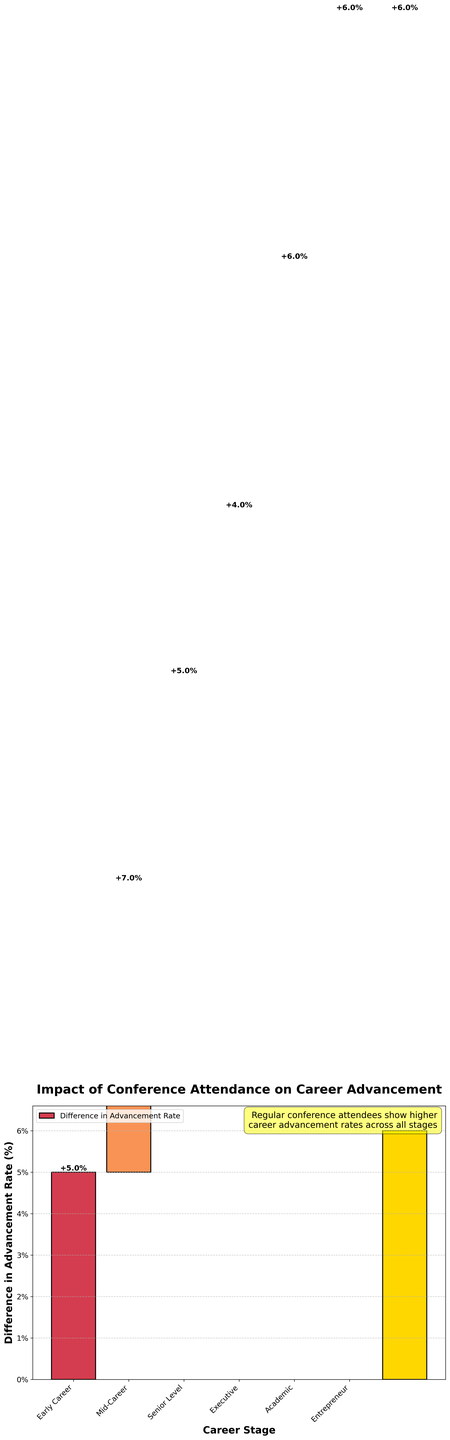What is the title of the figure? The title is usually positioned at the top of the figure and provides a summary of the main insight.
Answer: Impact of Conference Attendance on Career Advancement What does the y-axis represent? The y-axis label is provided to indicate what measurement is being shown vertical-wise in the plot.
Answer: Difference in Advancement Rate (%) Which career stage shows the highest difference in advancement rates between regular attendees and non-attendees? By examining the height of the bars, it's clear which career stage has the tallest bar.
Answer: Mid-Career How much is the difference in advancement rate at the Senior Level stage? Look at the specific bar for the Senior Level and check the label at the top of the bar.
Answer: 5% How many career stages are included in the analysis? Count the individual bars, excluding the total impact bar.
Answer: Six What is the total impact value for regular conference attendees vs. non-attendees? Look at the last bar, which represents the total impact, and read the value at the top of the bar.
Answer: 33% What is the combined difference in advancement rates for Academic and Entrepreneur stages? Find the values for both Academic and Entrepreneur stages, then add them together (6% + 6%).
Answer: 12% Which two career stages have equal differences in advancement rates between attendees and non-attendees? Compare the bars and identify which stages have the same height.
Answer: Early Career and Senior Level Is the difference in advancement rates higher for the Executive stage or the Early Career stage? Compare the heights of the bars for Executive and Early Career stages.
Answer: Early Career Explain why regular conference attendees have a higher career advancement rate across all stages, based on the figure. The figure shows consistently higher bars for regular attendees at each career stage, indicating a significant difference favoring conference attendees.
Answer: Conference attendees likely benefit from networking, learning opportunities, and other professional development activities at conferences 